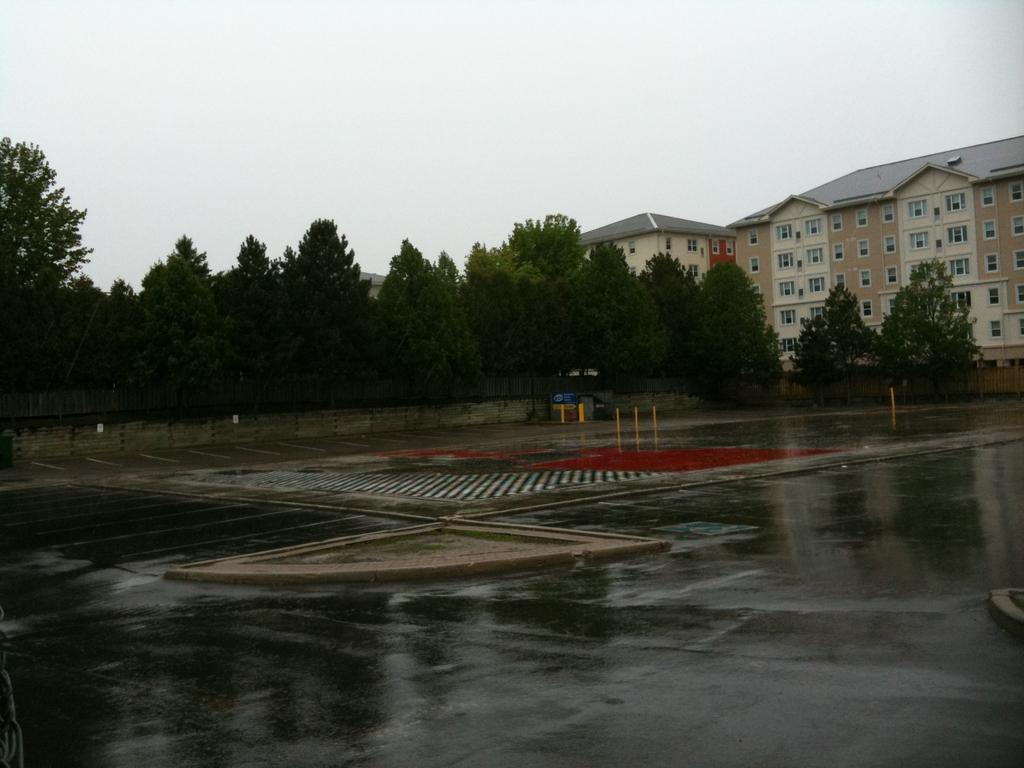What structures can be seen in the image? There are poles and buildings in the image. What type of surface is visible in the image? There is a road in the image. What can be found in the background of the image? There are trees, buildings, windows, and the sky visible in the background of the image. How many objects are present in the image? There are objects in the image, but the exact number is not specified. What type of skin is visible on the poles in the image? There is no skin visible on the poles in the image; they are likely made of metal or another material. Can you tell me where the stamp shop is located in the image? There is no mention of a stamp shop in the image or the provided facts. 